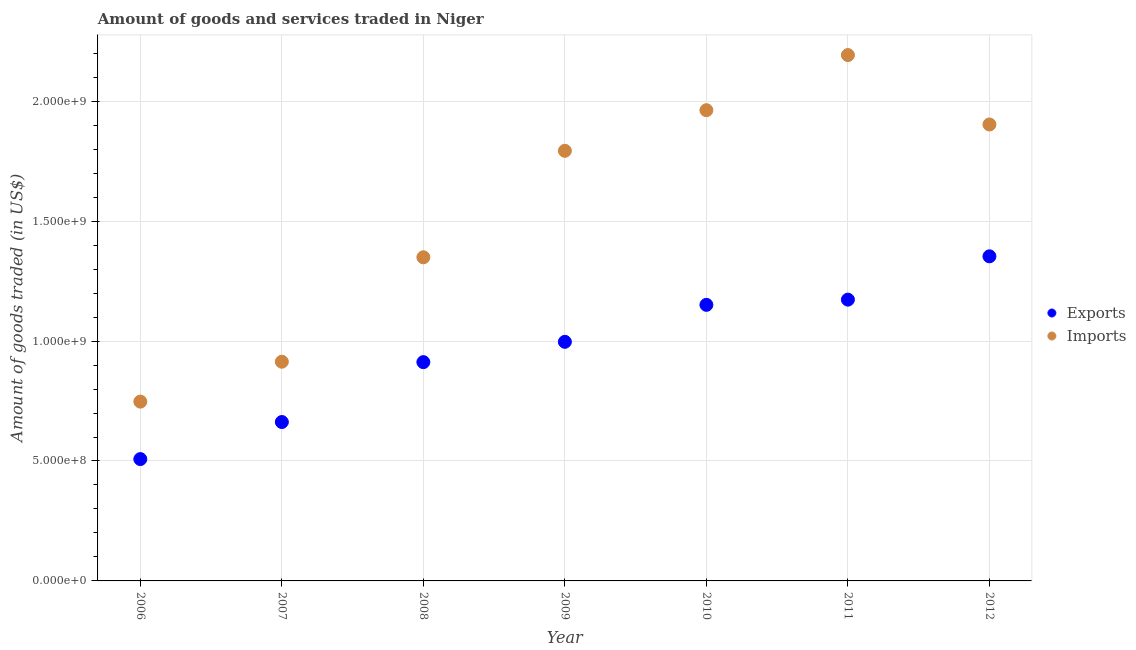How many different coloured dotlines are there?
Your answer should be compact. 2. What is the amount of goods exported in 2011?
Offer a very short reply. 1.17e+09. Across all years, what is the maximum amount of goods exported?
Ensure brevity in your answer.  1.35e+09. Across all years, what is the minimum amount of goods imported?
Give a very brief answer. 7.48e+08. In which year was the amount of goods exported maximum?
Give a very brief answer. 2012. In which year was the amount of goods exported minimum?
Your answer should be very brief. 2006. What is the total amount of goods exported in the graph?
Your answer should be very brief. 6.76e+09. What is the difference between the amount of goods exported in 2007 and that in 2011?
Ensure brevity in your answer.  -5.10e+08. What is the difference between the amount of goods exported in 2006 and the amount of goods imported in 2009?
Your answer should be compact. -1.29e+09. What is the average amount of goods imported per year?
Give a very brief answer. 1.55e+09. In the year 2008, what is the difference between the amount of goods exported and amount of goods imported?
Your response must be concise. -4.37e+08. What is the ratio of the amount of goods imported in 2009 to that in 2010?
Offer a terse response. 0.91. Is the amount of goods imported in 2009 less than that in 2011?
Your answer should be very brief. Yes. Is the difference between the amount of goods exported in 2006 and 2008 greater than the difference between the amount of goods imported in 2006 and 2008?
Your answer should be compact. Yes. What is the difference between the highest and the second highest amount of goods imported?
Your answer should be very brief. 2.30e+08. What is the difference between the highest and the lowest amount of goods exported?
Make the answer very short. 8.45e+08. Is the amount of goods imported strictly less than the amount of goods exported over the years?
Keep it short and to the point. No. How many dotlines are there?
Your answer should be very brief. 2. Does the graph contain any zero values?
Your answer should be very brief. No. How many legend labels are there?
Your answer should be very brief. 2. How are the legend labels stacked?
Your answer should be compact. Vertical. What is the title of the graph?
Offer a very short reply. Amount of goods and services traded in Niger. What is the label or title of the X-axis?
Your answer should be compact. Year. What is the label or title of the Y-axis?
Keep it short and to the point. Amount of goods traded (in US$). What is the Amount of goods traded (in US$) of Exports in 2006?
Your response must be concise. 5.08e+08. What is the Amount of goods traded (in US$) in Imports in 2006?
Offer a very short reply. 7.48e+08. What is the Amount of goods traded (in US$) in Exports in 2007?
Provide a short and direct response. 6.63e+08. What is the Amount of goods traded (in US$) of Imports in 2007?
Make the answer very short. 9.14e+08. What is the Amount of goods traded (in US$) of Exports in 2008?
Make the answer very short. 9.12e+08. What is the Amount of goods traded (in US$) in Imports in 2008?
Ensure brevity in your answer.  1.35e+09. What is the Amount of goods traded (in US$) in Exports in 2009?
Ensure brevity in your answer.  9.97e+08. What is the Amount of goods traded (in US$) in Imports in 2009?
Your answer should be very brief. 1.79e+09. What is the Amount of goods traded (in US$) of Exports in 2010?
Your answer should be very brief. 1.15e+09. What is the Amount of goods traded (in US$) in Imports in 2010?
Ensure brevity in your answer.  1.96e+09. What is the Amount of goods traded (in US$) in Exports in 2011?
Your response must be concise. 1.17e+09. What is the Amount of goods traded (in US$) of Imports in 2011?
Provide a succinct answer. 2.19e+09. What is the Amount of goods traded (in US$) in Exports in 2012?
Make the answer very short. 1.35e+09. What is the Amount of goods traded (in US$) in Imports in 2012?
Give a very brief answer. 1.90e+09. Across all years, what is the maximum Amount of goods traded (in US$) in Exports?
Make the answer very short. 1.35e+09. Across all years, what is the maximum Amount of goods traded (in US$) in Imports?
Offer a very short reply. 2.19e+09. Across all years, what is the minimum Amount of goods traded (in US$) in Exports?
Offer a very short reply. 5.08e+08. Across all years, what is the minimum Amount of goods traded (in US$) of Imports?
Give a very brief answer. 7.48e+08. What is the total Amount of goods traded (in US$) of Exports in the graph?
Make the answer very short. 6.76e+09. What is the total Amount of goods traded (in US$) of Imports in the graph?
Offer a very short reply. 1.09e+1. What is the difference between the Amount of goods traded (in US$) of Exports in 2006 and that in 2007?
Make the answer very short. -1.55e+08. What is the difference between the Amount of goods traded (in US$) in Imports in 2006 and that in 2007?
Your answer should be compact. -1.66e+08. What is the difference between the Amount of goods traded (in US$) in Exports in 2006 and that in 2008?
Provide a succinct answer. -4.04e+08. What is the difference between the Amount of goods traded (in US$) of Imports in 2006 and that in 2008?
Your response must be concise. -6.02e+08. What is the difference between the Amount of goods traded (in US$) of Exports in 2006 and that in 2009?
Ensure brevity in your answer.  -4.89e+08. What is the difference between the Amount of goods traded (in US$) of Imports in 2006 and that in 2009?
Ensure brevity in your answer.  -1.05e+09. What is the difference between the Amount of goods traded (in US$) of Exports in 2006 and that in 2010?
Provide a short and direct response. -6.43e+08. What is the difference between the Amount of goods traded (in US$) of Imports in 2006 and that in 2010?
Offer a very short reply. -1.22e+09. What is the difference between the Amount of goods traded (in US$) of Exports in 2006 and that in 2011?
Provide a short and direct response. -6.65e+08. What is the difference between the Amount of goods traded (in US$) of Imports in 2006 and that in 2011?
Provide a succinct answer. -1.44e+09. What is the difference between the Amount of goods traded (in US$) of Exports in 2006 and that in 2012?
Offer a terse response. -8.45e+08. What is the difference between the Amount of goods traded (in US$) in Imports in 2006 and that in 2012?
Offer a terse response. -1.16e+09. What is the difference between the Amount of goods traded (in US$) in Exports in 2007 and that in 2008?
Ensure brevity in your answer.  -2.50e+08. What is the difference between the Amount of goods traded (in US$) of Imports in 2007 and that in 2008?
Offer a very short reply. -4.35e+08. What is the difference between the Amount of goods traded (in US$) of Exports in 2007 and that in 2009?
Keep it short and to the point. -3.34e+08. What is the difference between the Amount of goods traded (in US$) in Imports in 2007 and that in 2009?
Give a very brief answer. -8.79e+08. What is the difference between the Amount of goods traded (in US$) of Exports in 2007 and that in 2010?
Provide a short and direct response. -4.88e+08. What is the difference between the Amount of goods traded (in US$) in Imports in 2007 and that in 2010?
Your answer should be very brief. -1.05e+09. What is the difference between the Amount of goods traded (in US$) of Exports in 2007 and that in 2011?
Offer a very short reply. -5.10e+08. What is the difference between the Amount of goods traded (in US$) in Imports in 2007 and that in 2011?
Provide a short and direct response. -1.28e+09. What is the difference between the Amount of goods traded (in US$) of Exports in 2007 and that in 2012?
Provide a short and direct response. -6.91e+08. What is the difference between the Amount of goods traded (in US$) of Imports in 2007 and that in 2012?
Provide a succinct answer. -9.89e+08. What is the difference between the Amount of goods traded (in US$) of Exports in 2008 and that in 2009?
Your answer should be very brief. -8.47e+07. What is the difference between the Amount of goods traded (in US$) in Imports in 2008 and that in 2009?
Your answer should be compact. -4.44e+08. What is the difference between the Amount of goods traded (in US$) in Exports in 2008 and that in 2010?
Your answer should be compact. -2.39e+08. What is the difference between the Amount of goods traded (in US$) in Imports in 2008 and that in 2010?
Your answer should be compact. -6.13e+08. What is the difference between the Amount of goods traded (in US$) in Exports in 2008 and that in 2011?
Keep it short and to the point. -2.61e+08. What is the difference between the Amount of goods traded (in US$) in Imports in 2008 and that in 2011?
Make the answer very short. -8.43e+08. What is the difference between the Amount of goods traded (in US$) in Exports in 2008 and that in 2012?
Your response must be concise. -4.41e+08. What is the difference between the Amount of goods traded (in US$) in Imports in 2008 and that in 2012?
Your answer should be compact. -5.54e+08. What is the difference between the Amount of goods traded (in US$) in Exports in 2009 and that in 2010?
Your response must be concise. -1.54e+08. What is the difference between the Amount of goods traded (in US$) in Imports in 2009 and that in 2010?
Your answer should be very brief. -1.69e+08. What is the difference between the Amount of goods traded (in US$) of Exports in 2009 and that in 2011?
Ensure brevity in your answer.  -1.76e+08. What is the difference between the Amount of goods traded (in US$) in Imports in 2009 and that in 2011?
Offer a terse response. -3.99e+08. What is the difference between the Amount of goods traded (in US$) in Exports in 2009 and that in 2012?
Your response must be concise. -3.56e+08. What is the difference between the Amount of goods traded (in US$) in Imports in 2009 and that in 2012?
Keep it short and to the point. -1.10e+08. What is the difference between the Amount of goods traded (in US$) of Exports in 2010 and that in 2011?
Ensure brevity in your answer.  -2.17e+07. What is the difference between the Amount of goods traded (in US$) in Imports in 2010 and that in 2011?
Your response must be concise. -2.30e+08. What is the difference between the Amount of goods traded (in US$) of Exports in 2010 and that in 2012?
Give a very brief answer. -2.02e+08. What is the difference between the Amount of goods traded (in US$) of Imports in 2010 and that in 2012?
Offer a terse response. 5.96e+07. What is the difference between the Amount of goods traded (in US$) in Exports in 2011 and that in 2012?
Keep it short and to the point. -1.81e+08. What is the difference between the Amount of goods traded (in US$) in Imports in 2011 and that in 2012?
Make the answer very short. 2.89e+08. What is the difference between the Amount of goods traded (in US$) in Exports in 2006 and the Amount of goods traded (in US$) in Imports in 2007?
Give a very brief answer. -4.06e+08. What is the difference between the Amount of goods traded (in US$) of Exports in 2006 and the Amount of goods traded (in US$) of Imports in 2008?
Give a very brief answer. -8.41e+08. What is the difference between the Amount of goods traded (in US$) of Exports in 2006 and the Amount of goods traded (in US$) of Imports in 2009?
Provide a short and direct response. -1.29e+09. What is the difference between the Amount of goods traded (in US$) of Exports in 2006 and the Amount of goods traded (in US$) of Imports in 2010?
Offer a very short reply. -1.45e+09. What is the difference between the Amount of goods traded (in US$) in Exports in 2006 and the Amount of goods traded (in US$) in Imports in 2011?
Your answer should be very brief. -1.68e+09. What is the difference between the Amount of goods traded (in US$) in Exports in 2006 and the Amount of goods traded (in US$) in Imports in 2012?
Your response must be concise. -1.40e+09. What is the difference between the Amount of goods traded (in US$) of Exports in 2007 and the Amount of goods traded (in US$) of Imports in 2008?
Offer a terse response. -6.87e+08. What is the difference between the Amount of goods traded (in US$) in Exports in 2007 and the Amount of goods traded (in US$) in Imports in 2009?
Make the answer very short. -1.13e+09. What is the difference between the Amount of goods traded (in US$) of Exports in 2007 and the Amount of goods traded (in US$) of Imports in 2010?
Your answer should be very brief. -1.30e+09. What is the difference between the Amount of goods traded (in US$) in Exports in 2007 and the Amount of goods traded (in US$) in Imports in 2011?
Your response must be concise. -1.53e+09. What is the difference between the Amount of goods traded (in US$) in Exports in 2007 and the Amount of goods traded (in US$) in Imports in 2012?
Make the answer very short. -1.24e+09. What is the difference between the Amount of goods traded (in US$) in Exports in 2008 and the Amount of goods traded (in US$) in Imports in 2009?
Your response must be concise. -8.81e+08. What is the difference between the Amount of goods traded (in US$) in Exports in 2008 and the Amount of goods traded (in US$) in Imports in 2010?
Ensure brevity in your answer.  -1.05e+09. What is the difference between the Amount of goods traded (in US$) in Exports in 2008 and the Amount of goods traded (in US$) in Imports in 2011?
Keep it short and to the point. -1.28e+09. What is the difference between the Amount of goods traded (in US$) in Exports in 2008 and the Amount of goods traded (in US$) in Imports in 2012?
Your response must be concise. -9.91e+08. What is the difference between the Amount of goods traded (in US$) of Exports in 2009 and the Amount of goods traded (in US$) of Imports in 2010?
Your response must be concise. -9.66e+08. What is the difference between the Amount of goods traded (in US$) in Exports in 2009 and the Amount of goods traded (in US$) in Imports in 2011?
Provide a short and direct response. -1.20e+09. What is the difference between the Amount of goods traded (in US$) of Exports in 2009 and the Amount of goods traded (in US$) of Imports in 2012?
Your response must be concise. -9.06e+08. What is the difference between the Amount of goods traded (in US$) of Exports in 2010 and the Amount of goods traded (in US$) of Imports in 2011?
Your response must be concise. -1.04e+09. What is the difference between the Amount of goods traded (in US$) of Exports in 2010 and the Amount of goods traded (in US$) of Imports in 2012?
Your answer should be compact. -7.52e+08. What is the difference between the Amount of goods traded (in US$) of Exports in 2011 and the Amount of goods traded (in US$) of Imports in 2012?
Offer a very short reply. -7.30e+08. What is the average Amount of goods traded (in US$) of Exports per year?
Your answer should be compact. 9.65e+08. What is the average Amount of goods traded (in US$) in Imports per year?
Provide a succinct answer. 1.55e+09. In the year 2006, what is the difference between the Amount of goods traded (in US$) in Exports and Amount of goods traded (in US$) in Imports?
Offer a very short reply. -2.40e+08. In the year 2007, what is the difference between the Amount of goods traded (in US$) of Exports and Amount of goods traded (in US$) of Imports?
Offer a terse response. -2.51e+08. In the year 2008, what is the difference between the Amount of goods traded (in US$) of Exports and Amount of goods traded (in US$) of Imports?
Your response must be concise. -4.37e+08. In the year 2009, what is the difference between the Amount of goods traded (in US$) in Exports and Amount of goods traded (in US$) in Imports?
Your answer should be compact. -7.96e+08. In the year 2010, what is the difference between the Amount of goods traded (in US$) of Exports and Amount of goods traded (in US$) of Imports?
Ensure brevity in your answer.  -8.12e+08. In the year 2011, what is the difference between the Amount of goods traded (in US$) of Exports and Amount of goods traded (in US$) of Imports?
Provide a short and direct response. -1.02e+09. In the year 2012, what is the difference between the Amount of goods traded (in US$) of Exports and Amount of goods traded (in US$) of Imports?
Ensure brevity in your answer.  -5.50e+08. What is the ratio of the Amount of goods traded (in US$) in Exports in 2006 to that in 2007?
Your response must be concise. 0.77. What is the ratio of the Amount of goods traded (in US$) in Imports in 2006 to that in 2007?
Give a very brief answer. 0.82. What is the ratio of the Amount of goods traded (in US$) of Exports in 2006 to that in 2008?
Keep it short and to the point. 0.56. What is the ratio of the Amount of goods traded (in US$) in Imports in 2006 to that in 2008?
Your response must be concise. 0.55. What is the ratio of the Amount of goods traded (in US$) in Exports in 2006 to that in 2009?
Ensure brevity in your answer.  0.51. What is the ratio of the Amount of goods traded (in US$) of Imports in 2006 to that in 2009?
Your answer should be very brief. 0.42. What is the ratio of the Amount of goods traded (in US$) in Exports in 2006 to that in 2010?
Provide a succinct answer. 0.44. What is the ratio of the Amount of goods traded (in US$) in Imports in 2006 to that in 2010?
Ensure brevity in your answer.  0.38. What is the ratio of the Amount of goods traded (in US$) in Exports in 2006 to that in 2011?
Offer a very short reply. 0.43. What is the ratio of the Amount of goods traded (in US$) of Imports in 2006 to that in 2011?
Your answer should be compact. 0.34. What is the ratio of the Amount of goods traded (in US$) of Exports in 2006 to that in 2012?
Make the answer very short. 0.38. What is the ratio of the Amount of goods traded (in US$) of Imports in 2006 to that in 2012?
Keep it short and to the point. 0.39. What is the ratio of the Amount of goods traded (in US$) of Exports in 2007 to that in 2008?
Your answer should be compact. 0.73. What is the ratio of the Amount of goods traded (in US$) in Imports in 2007 to that in 2008?
Provide a short and direct response. 0.68. What is the ratio of the Amount of goods traded (in US$) in Exports in 2007 to that in 2009?
Ensure brevity in your answer.  0.66. What is the ratio of the Amount of goods traded (in US$) in Imports in 2007 to that in 2009?
Provide a succinct answer. 0.51. What is the ratio of the Amount of goods traded (in US$) in Exports in 2007 to that in 2010?
Make the answer very short. 0.58. What is the ratio of the Amount of goods traded (in US$) of Imports in 2007 to that in 2010?
Give a very brief answer. 0.47. What is the ratio of the Amount of goods traded (in US$) of Exports in 2007 to that in 2011?
Your answer should be very brief. 0.56. What is the ratio of the Amount of goods traded (in US$) of Imports in 2007 to that in 2011?
Ensure brevity in your answer.  0.42. What is the ratio of the Amount of goods traded (in US$) in Exports in 2007 to that in 2012?
Provide a succinct answer. 0.49. What is the ratio of the Amount of goods traded (in US$) of Imports in 2007 to that in 2012?
Give a very brief answer. 0.48. What is the ratio of the Amount of goods traded (in US$) in Exports in 2008 to that in 2009?
Ensure brevity in your answer.  0.92. What is the ratio of the Amount of goods traded (in US$) in Imports in 2008 to that in 2009?
Your response must be concise. 0.75. What is the ratio of the Amount of goods traded (in US$) in Exports in 2008 to that in 2010?
Offer a very short reply. 0.79. What is the ratio of the Amount of goods traded (in US$) of Imports in 2008 to that in 2010?
Give a very brief answer. 0.69. What is the ratio of the Amount of goods traded (in US$) of Exports in 2008 to that in 2011?
Your answer should be compact. 0.78. What is the ratio of the Amount of goods traded (in US$) in Imports in 2008 to that in 2011?
Offer a very short reply. 0.62. What is the ratio of the Amount of goods traded (in US$) in Exports in 2008 to that in 2012?
Provide a short and direct response. 0.67. What is the ratio of the Amount of goods traded (in US$) of Imports in 2008 to that in 2012?
Provide a short and direct response. 0.71. What is the ratio of the Amount of goods traded (in US$) in Exports in 2009 to that in 2010?
Your answer should be very brief. 0.87. What is the ratio of the Amount of goods traded (in US$) in Imports in 2009 to that in 2010?
Offer a terse response. 0.91. What is the ratio of the Amount of goods traded (in US$) in Exports in 2009 to that in 2011?
Provide a short and direct response. 0.85. What is the ratio of the Amount of goods traded (in US$) in Imports in 2009 to that in 2011?
Give a very brief answer. 0.82. What is the ratio of the Amount of goods traded (in US$) in Exports in 2009 to that in 2012?
Ensure brevity in your answer.  0.74. What is the ratio of the Amount of goods traded (in US$) of Imports in 2009 to that in 2012?
Provide a succinct answer. 0.94. What is the ratio of the Amount of goods traded (in US$) in Exports in 2010 to that in 2011?
Give a very brief answer. 0.98. What is the ratio of the Amount of goods traded (in US$) in Imports in 2010 to that in 2011?
Offer a terse response. 0.9. What is the ratio of the Amount of goods traded (in US$) in Exports in 2010 to that in 2012?
Keep it short and to the point. 0.85. What is the ratio of the Amount of goods traded (in US$) of Imports in 2010 to that in 2012?
Offer a terse response. 1.03. What is the ratio of the Amount of goods traded (in US$) of Exports in 2011 to that in 2012?
Ensure brevity in your answer.  0.87. What is the ratio of the Amount of goods traded (in US$) of Imports in 2011 to that in 2012?
Make the answer very short. 1.15. What is the difference between the highest and the second highest Amount of goods traded (in US$) of Exports?
Your response must be concise. 1.81e+08. What is the difference between the highest and the second highest Amount of goods traded (in US$) of Imports?
Keep it short and to the point. 2.30e+08. What is the difference between the highest and the lowest Amount of goods traded (in US$) in Exports?
Your response must be concise. 8.45e+08. What is the difference between the highest and the lowest Amount of goods traded (in US$) in Imports?
Keep it short and to the point. 1.44e+09. 